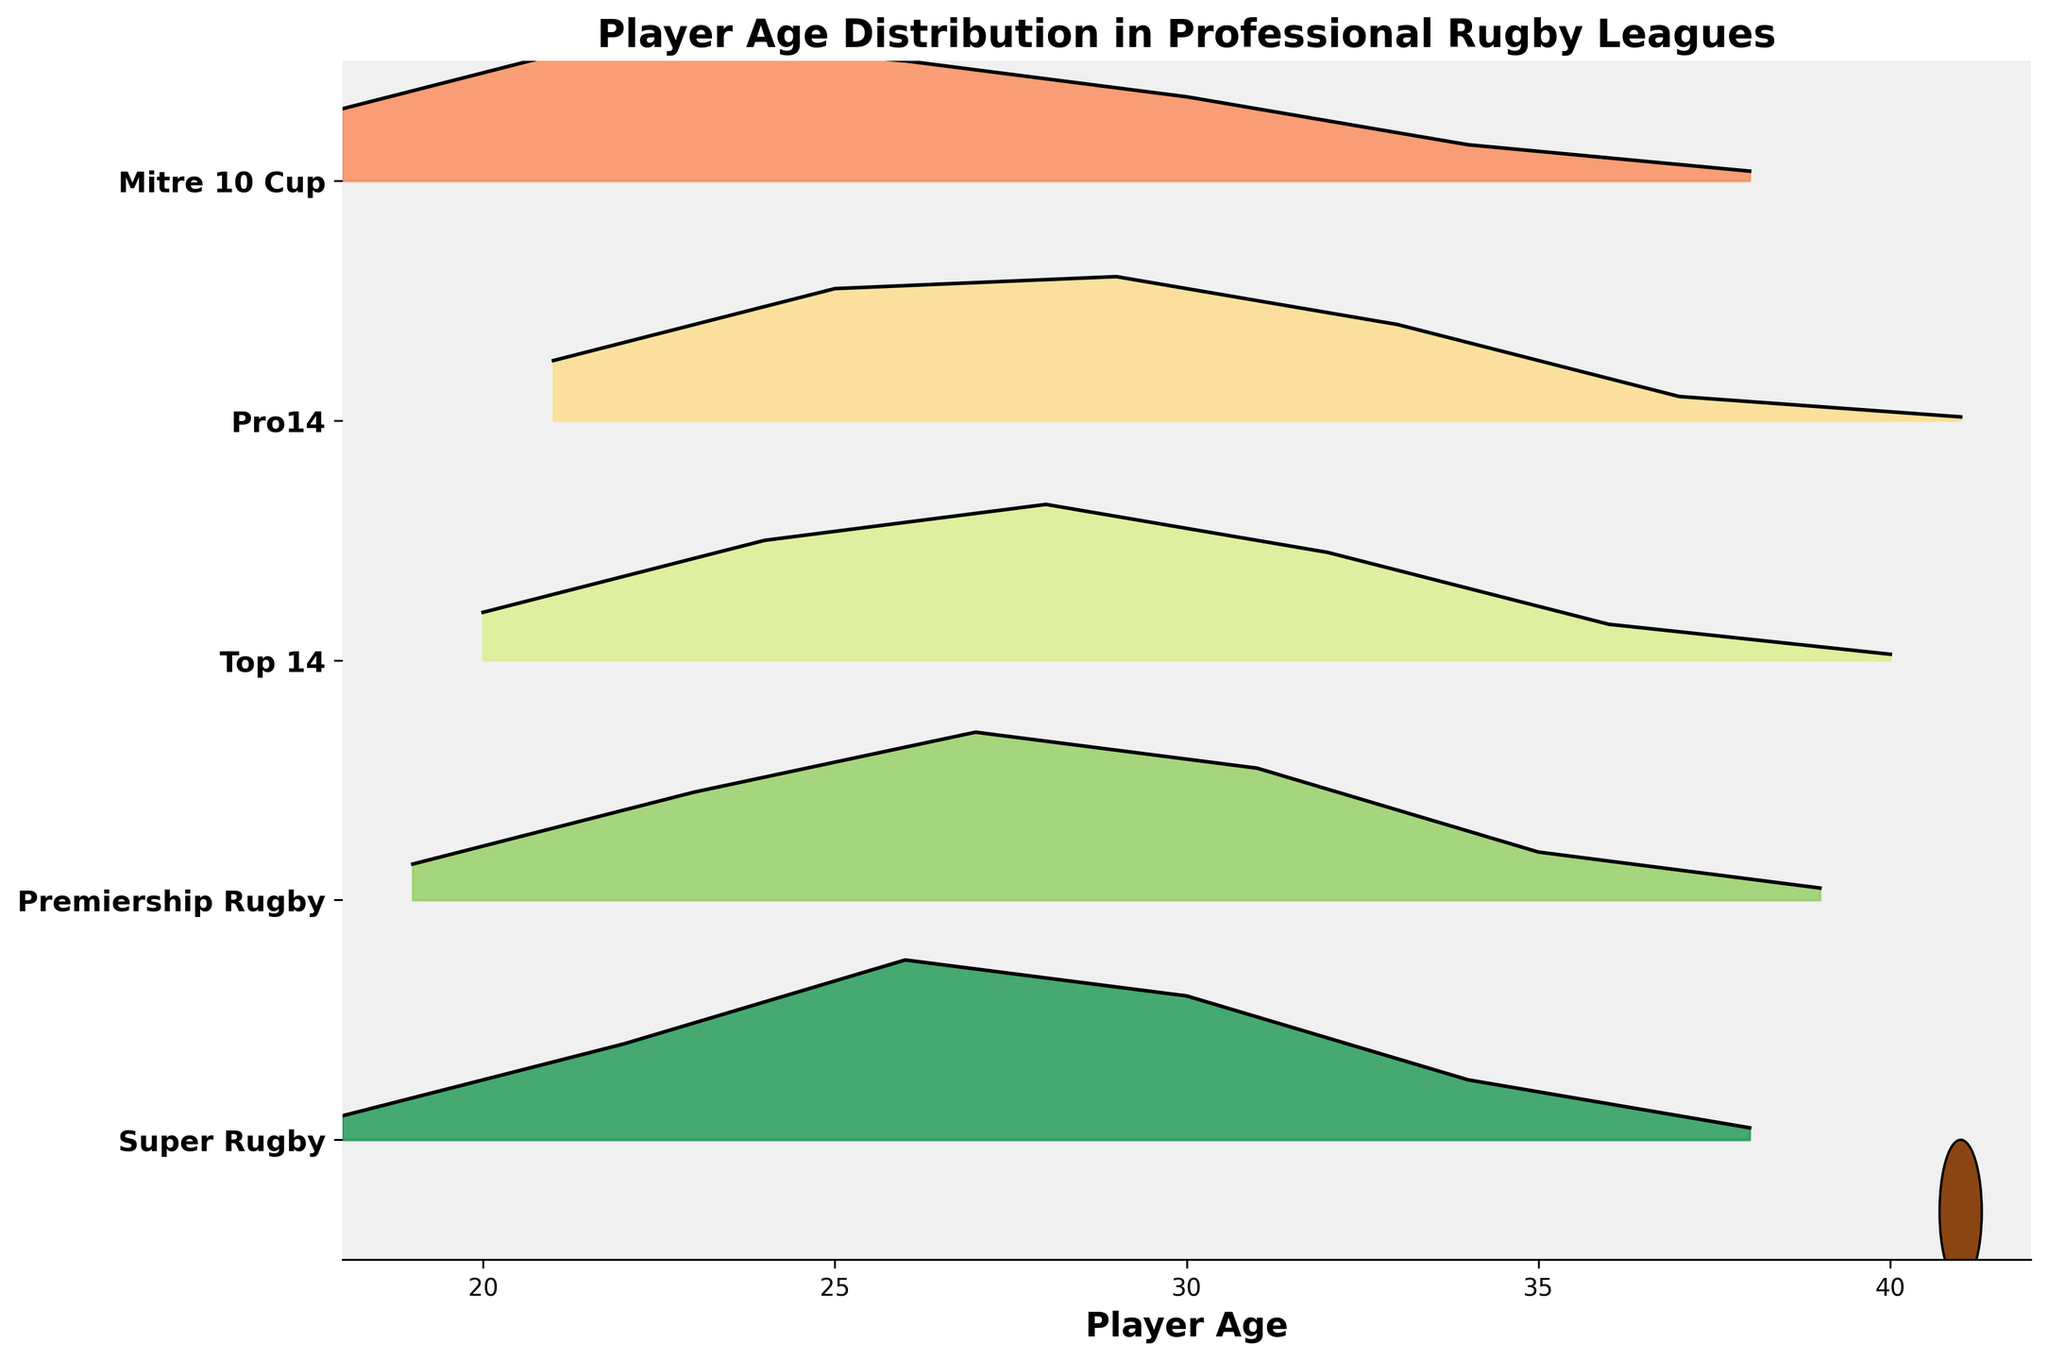Which league has the youngest peak player age distribution? The peak player age distribution is indicated by the highest density point on each ridgeline. By observing the plots, Mitre 10 Cup peaks around age 22.
Answer: Mitre 10 Cup Which league shows the lowest density for players aged 41? By examining the league ridgelines, only Pro14 and Top 14 extend to age 41, with Pro14 showing a very low density for this age group.
Answer: Pro14 How does the age distribution in Super Rugby compare to Premiership Rugby at age 30? By comparing the density of Super Rugby and Premiership Rugby at age 30, Super Rugby has a higher density than Premiership Rugby.
Answer: Super Rugby has a higher density What is the range of ages covered in the Top 14 league? Observing the Top 14 ridgeline, it spans from age 20 to roughly age 40.
Answer: 20 to 40 years Which league has the highest peak density and at what age range does it occur? The highest density is found by comparing the peaks of each league's ridgeline. Super Rugby peaks at 0.15 density around age 26.
Answer: Super Rugby at age 26 Is there a significant difference in the age distributions of Mitre 10 Cup and Pro14? By comparing the ridgelines of Mitre 10 Cup and Pro14, Mitre 10 Cup peaks earlier at age 22, while Pro14 peaks around age 25 showing a slower decline in density.
Answer: Yes, there is a difference At which age do all leagues show above 0.10 density? Looking at each ridgeline, ages 25 and 26 have above 0.10 density across Super Rugby, Premiership Rugby, Top 14, and Pro14.
Answer: 25 and 26 Do any leagues have a density greater than 0.08 for players above age 34? By observing the ridgelines, none of the leagues show a density greater than 0.08 for players above age 34.
Answer: No Which league shows the greatest variability in age distribution regardless of density? Variability is indicated by how spread out the age distributions are. Super Rugby and Premiership Rugby show distribution from 18 to 39, indicating more variability.
Answer: Super Rugby and Premiership Rugby 